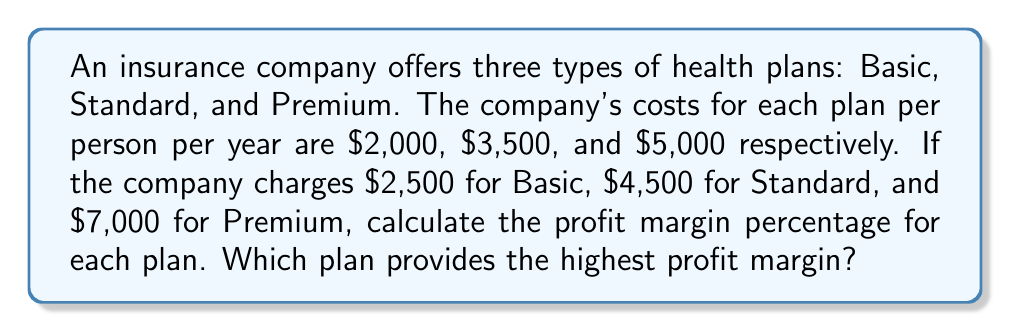Teach me how to tackle this problem. To calculate the profit margin percentage for each plan, we'll use the formula:

$$ \text{Profit Margin} = \frac{\text{Revenue} - \text{Cost}}{\text{Revenue}} \times 100\% $$

1. Basic Plan:
   Revenue = $2,500
   Cost = $2,000
   $$ \text{Profit Margin}_{\text{Basic}} = \frac{2500 - 2000}{2500} \times 100\% = \frac{500}{2500} \times 100\% = 20\% $$

2. Standard Plan:
   Revenue = $4,500
   Cost = $3,500
   $$ \text{Profit Margin}_{\text{Standard}} = \frac{4500 - 3500}{4500} \times 100\% = \frac{1000}{4500} \times 100\% = 22.22\% $$

3. Premium Plan:
   Revenue = $7,000
   Cost = $5,000
   $$ \text{Profit Margin}_{\text{Premium}} = \frac{7000 - 5000}{7000} \times 100\% = \frac{2000}{7000} \times 100\% = 28.57\% $$

Comparing the profit margins:
Basic: 20%
Standard: 22.22%
Premium: 28.57%

The Premium plan provides the highest profit margin at 28.57%.
Answer: The profit margin percentages are:
Basic: 20%
Standard: 22.22%
Premium: 28.57%

The Premium plan provides the highest profit margin. 